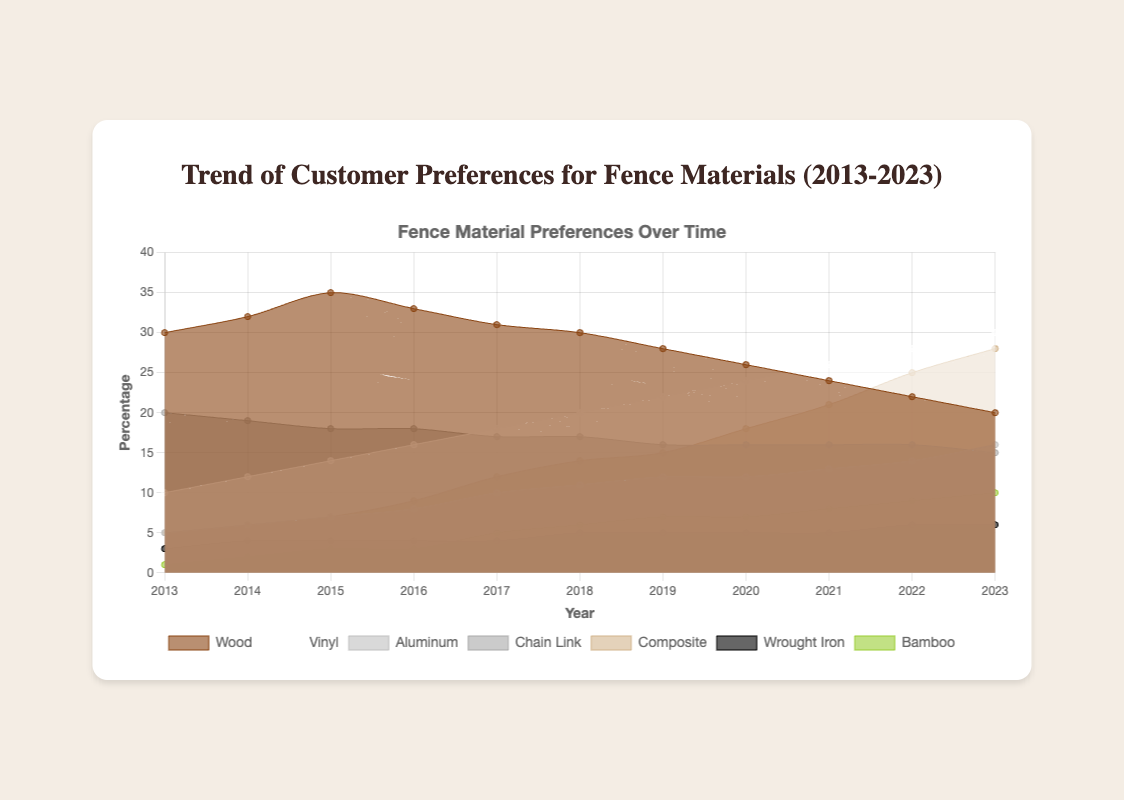What's the trend for wood fencing preferences from 2013 to 2023? The data for wood fencing trends show the following values: [30, 32, 35, 33, 31, 30, 28, 26, 24, 22, 20]. The trend starts at 30% in 2013, peaks at 35% in 2015, and then continuously declines to 20% in 2023.
Answer: Decreasing Which year saw the highest percentage preference for composite fencing? By examining the composite fence data: [5, 6, 7, 9, 12, 14, 15, 18, 21, 25, 28], the highest value of 28% occurs in 2023.
Answer: 2023 How does the preference for vinyl fencing in 2023 compare to that for wood fencing in the same year? In 2023, the preference for vinyl fencing is 30%, while that for wood fencing is 20%. So, vinyl is preferred 10% more than wood.
Answer: Vinyl is 10% higher What is the average percentage preference for bamboo fencing across the given years? To compute the average, sum the bamboo data: [1, 2, 3, 3, 5, 6, 7, 7, 8, 9, 10] = 61. There are 11 years, so the average is 61/11 ≈ 5.55%.
Answer: 5.55% Which material shows a steadily increasing preference every year? By examining the trend data for each material, vinyl [10, 12, 14, 16, 18, 20, 22, 24, 26, 28, 30] is the only one that consistently increases each year.
Answer: Vinyl What were the percentage preferences for aluminum and chain link fencing in 2016, and how do they compare? In 2016, aluminum has a preference of 8%, while chain link has a preference of 18%. Aluminum is 10% less preferred than chain link in that year.
Answer: Aluminum is 10% less How has the preference for bamboo fencing changed from 2013 to 2023? In 2013, bamboo had a preference of 1%, and by 2023 it increased to 10%. This shows a 9% increase over the decade.
Answer: Increased by 9% Which fencing material had the least preference in 2019? The data for 2019 shows the following preferences: wood: 28%, vinyl: 22%, aluminum: 12%, chain link: 16%, composite: 15%, wrought iron: 5%, bamboo: 7%. Wrought iron has the lowest preference at 5%.
Answer: Wrought iron How does the preference for wrought iron in 2023 compare to that for composite fencing in the same year? In 2023, wrought iron has a preference of 6%, while composite fencing is at 28%. Composite is preferred 22% more than wrought iron.
Answer: Composite is 22% higher How has the preference for chain link fencing changed from 2013 to 2023? The chain link fencing data shows [20, 19, 18, 18, 17, 17, 16, 16, 16, 16, 15]. From 2013 to 2023, the preference has decreased by 5%.
Answer: Decreased by 5% 